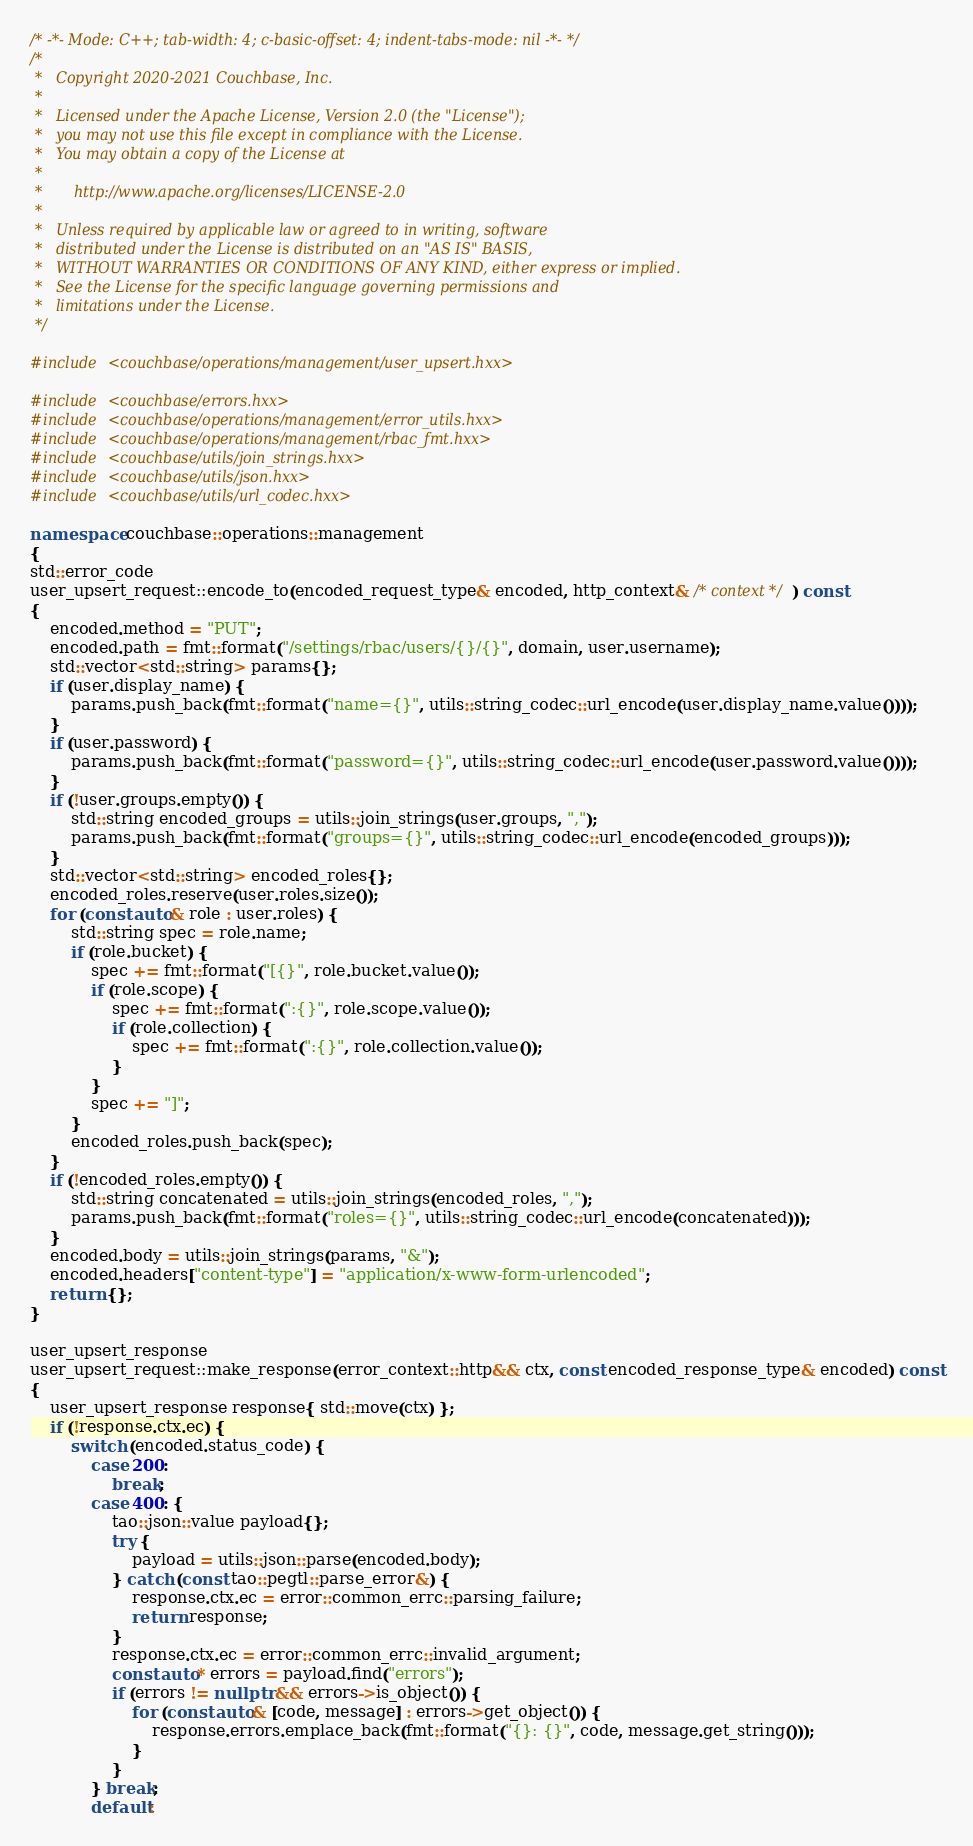Convert code to text. <code><loc_0><loc_0><loc_500><loc_500><_C++_>/* -*- Mode: C++; tab-width: 4; c-basic-offset: 4; indent-tabs-mode: nil -*- */
/*
 *   Copyright 2020-2021 Couchbase, Inc.
 *
 *   Licensed under the Apache License, Version 2.0 (the "License");
 *   you may not use this file except in compliance with the License.
 *   You may obtain a copy of the License at
 *
 *       http://www.apache.org/licenses/LICENSE-2.0
 *
 *   Unless required by applicable law or agreed to in writing, software
 *   distributed under the License is distributed on an "AS IS" BASIS,
 *   WITHOUT WARRANTIES OR CONDITIONS OF ANY KIND, either express or implied.
 *   See the License for the specific language governing permissions and
 *   limitations under the License.
 */

#include <couchbase/operations/management/user_upsert.hxx>

#include <couchbase/errors.hxx>
#include <couchbase/operations/management/error_utils.hxx>
#include <couchbase/operations/management/rbac_fmt.hxx>
#include <couchbase/utils/join_strings.hxx>
#include <couchbase/utils/json.hxx>
#include <couchbase/utils/url_codec.hxx>

namespace couchbase::operations::management
{
std::error_code
user_upsert_request::encode_to(encoded_request_type& encoded, http_context& /* context */) const
{
    encoded.method = "PUT";
    encoded.path = fmt::format("/settings/rbac/users/{}/{}", domain, user.username);
    std::vector<std::string> params{};
    if (user.display_name) {
        params.push_back(fmt::format("name={}", utils::string_codec::url_encode(user.display_name.value())));
    }
    if (user.password) {
        params.push_back(fmt::format("password={}", utils::string_codec::url_encode(user.password.value())));
    }
    if (!user.groups.empty()) {
        std::string encoded_groups = utils::join_strings(user.groups, ",");
        params.push_back(fmt::format("groups={}", utils::string_codec::url_encode(encoded_groups)));
    }
    std::vector<std::string> encoded_roles{};
    encoded_roles.reserve(user.roles.size());
    for (const auto& role : user.roles) {
        std::string spec = role.name;
        if (role.bucket) {
            spec += fmt::format("[{}", role.bucket.value());
            if (role.scope) {
                spec += fmt::format(":{}", role.scope.value());
                if (role.collection) {
                    spec += fmt::format(":{}", role.collection.value());
                }
            }
            spec += "]";
        }
        encoded_roles.push_back(spec);
    }
    if (!encoded_roles.empty()) {
        std::string concatenated = utils::join_strings(encoded_roles, ",");
        params.push_back(fmt::format("roles={}", utils::string_codec::url_encode(concatenated)));
    }
    encoded.body = utils::join_strings(params, "&");
    encoded.headers["content-type"] = "application/x-www-form-urlencoded";
    return {};
}

user_upsert_response
user_upsert_request::make_response(error_context::http&& ctx, const encoded_response_type& encoded) const
{
    user_upsert_response response{ std::move(ctx) };
    if (!response.ctx.ec) {
        switch (encoded.status_code) {
            case 200:
                break;
            case 400: {
                tao::json::value payload{};
                try {
                    payload = utils::json::parse(encoded.body);
                } catch (const tao::pegtl::parse_error&) {
                    response.ctx.ec = error::common_errc::parsing_failure;
                    return response;
                }
                response.ctx.ec = error::common_errc::invalid_argument;
                const auto* errors = payload.find("errors");
                if (errors != nullptr && errors->is_object()) {
                    for (const auto& [code, message] : errors->get_object()) {
                        response.errors.emplace_back(fmt::format("{}: {}", code, message.get_string()));
                    }
                }
            } break;
            default:</code> 